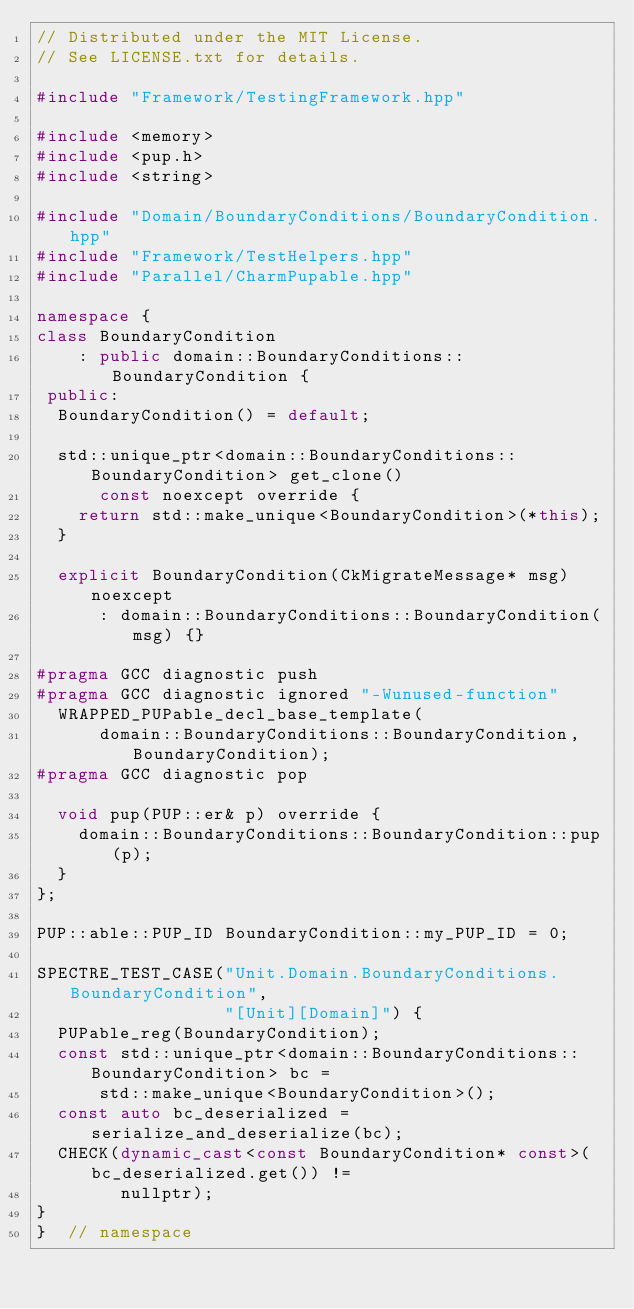<code> <loc_0><loc_0><loc_500><loc_500><_C++_>// Distributed under the MIT License.
// See LICENSE.txt for details.

#include "Framework/TestingFramework.hpp"

#include <memory>
#include <pup.h>
#include <string>

#include "Domain/BoundaryConditions/BoundaryCondition.hpp"
#include "Framework/TestHelpers.hpp"
#include "Parallel/CharmPupable.hpp"

namespace {
class BoundaryCondition
    : public domain::BoundaryConditions::BoundaryCondition {
 public:
  BoundaryCondition() = default;

  std::unique_ptr<domain::BoundaryConditions::BoundaryCondition> get_clone()
      const noexcept override {
    return std::make_unique<BoundaryCondition>(*this);
  }

  explicit BoundaryCondition(CkMigrateMessage* msg) noexcept
      : domain::BoundaryConditions::BoundaryCondition(msg) {}

#pragma GCC diagnostic push
#pragma GCC diagnostic ignored "-Wunused-function"
  WRAPPED_PUPable_decl_base_template(
      domain::BoundaryConditions::BoundaryCondition, BoundaryCondition);
#pragma GCC diagnostic pop

  void pup(PUP::er& p) override {
    domain::BoundaryConditions::BoundaryCondition::pup(p);
  }
};

PUP::able::PUP_ID BoundaryCondition::my_PUP_ID = 0;

SPECTRE_TEST_CASE("Unit.Domain.BoundaryConditions.BoundaryCondition",
                  "[Unit][Domain]") {
  PUPable_reg(BoundaryCondition);
  const std::unique_ptr<domain::BoundaryConditions::BoundaryCondition> bc =
      std::make_unique<BoundaryCondition>();
  const auto bc_deserialized = serialize_and_deserialize(bc);
  CHECK(dynamic_cast<const BoundaryCondition* const>(bc_deserialized.get()) !=
        nullptr);
}
}  // namespace
</code> 